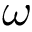Convert formula to latex. <formula><loc_0><loc_0><loc_500><loc_500>\omega</formula> 